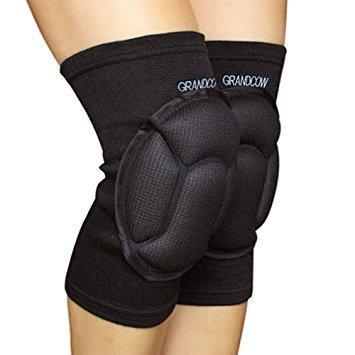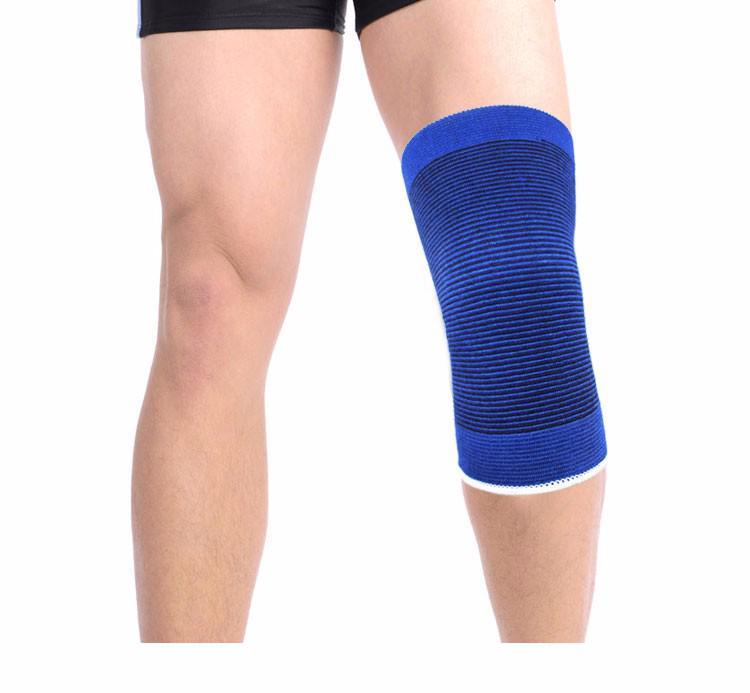The first image is the image on the left, the second image is the image on the right. Evaluate the accuracy of this statement regarding the images: "Two black kneepads are modeled in one image, but a second image shows only one kneepad of a different color.". Is it true? Answer yes or no. Yes. The first image is the image on the left, the second image is the image on the right. Assess this claim about the two images: "There is a single blue kneepad in one image and two black kneepads in the other image.". Correct or not? Answer yes or no. Yes. 